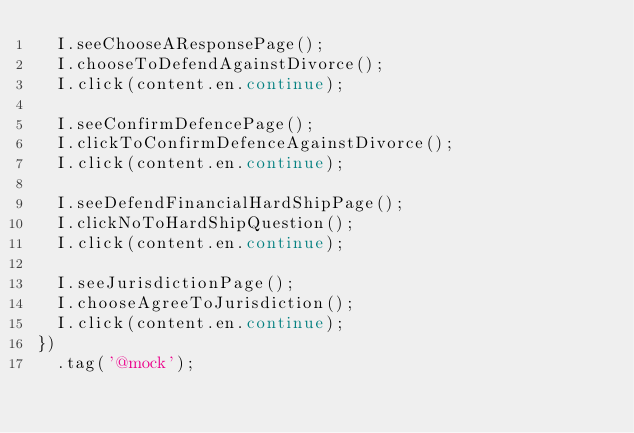Convert code to text. <code><loc_0><loc_0><loc_500><loc_500><_JavaScript_>  I.seeChooseAResponsePage();
  I.chooseToDefendAgainstDivorce();
  I.click(content.en.continue);

  I.seeConfirmDefencePage();
  I.clickToConfirmDefenceAgainstDivorce();
  I.click(content.en.continue);

  I.seeDefendFinancialHardShipPage();
  I.clickNoToHardShipQuestion();
  I.click(content.en.continue);

  I.seeJurisdictionPage();
  I.chooseAgreeToJurisdiction();
  I.click(content.en.continue);
})
  .tag('@mock');
</code> 